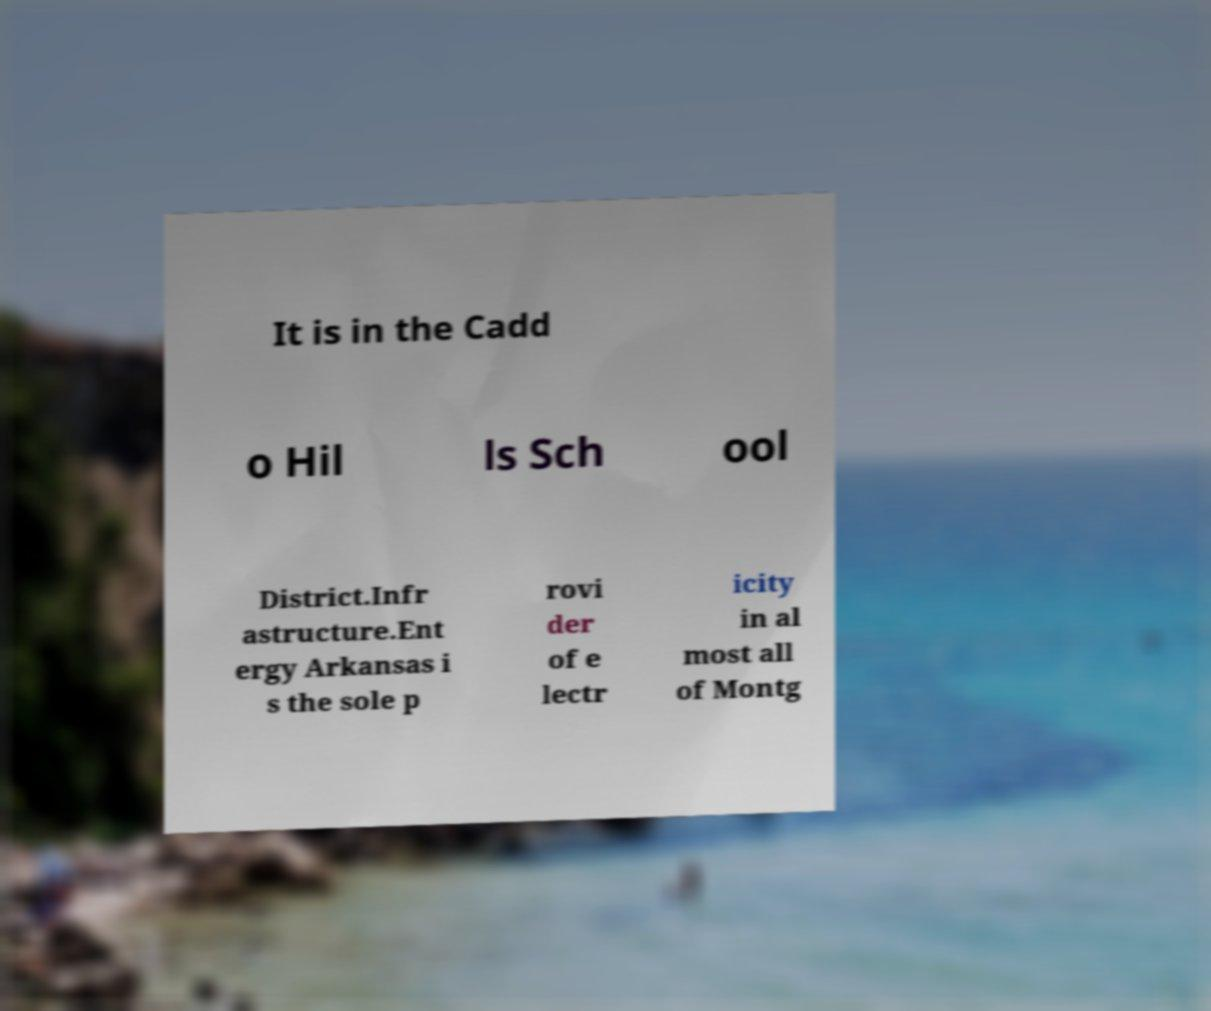Please identify and transcribe the text found in this image. It is in the Cadd o Hil ls Sch ool District.Infr astructure.Ent ergy Arkansas i s the sole p rovi der of e lectr icity in al most all of Montg 